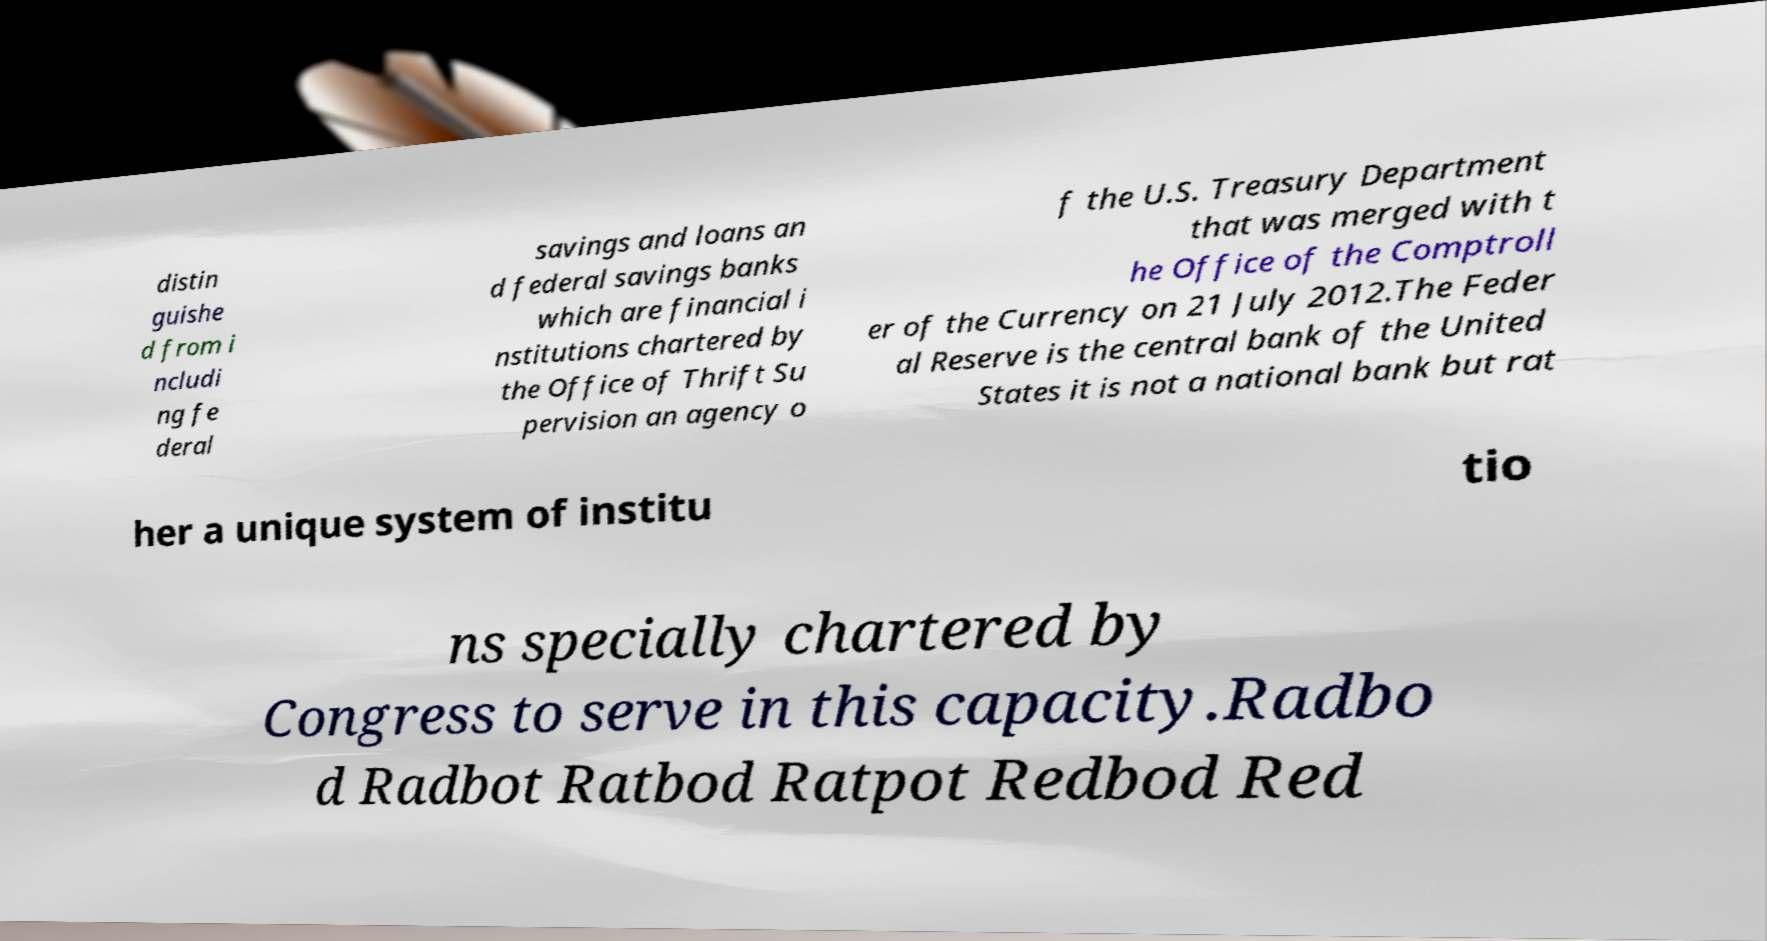What messages or text are displayed in this image? I need them in a readable, typed format. distin guishe d from i ncludi ng fe deral savings and loans an d federal savings banks which are financial i nstitutions chartered by the Office of Thrift Su pervision an agency o f the U.S. Treasury Department that was merged with t he Office of the Comptroll er of the Currency on 21 July 2012.The Feder al Reserve is the central bank of the United States it is not a national bank but rat her a unique system of institu tio ns specially chartered by Congress to serve in this capacity.Radbo d Radbot Ratbod Ratpot Redbod Red 